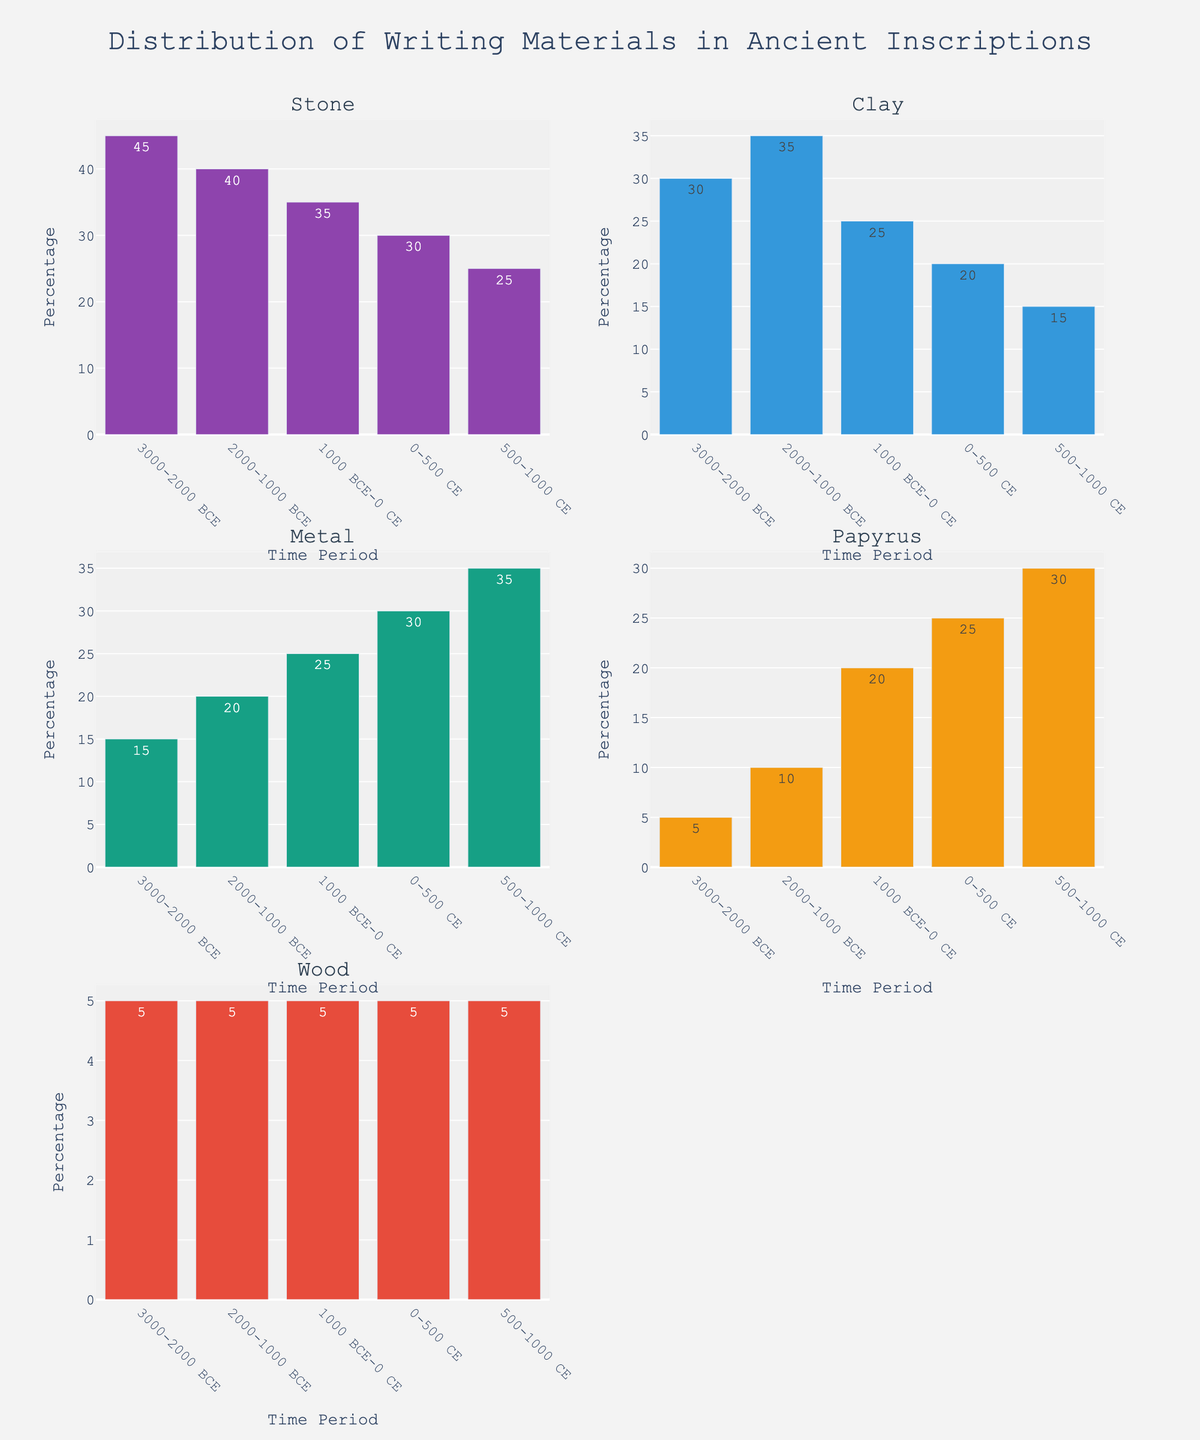What is the title of the figure? The title of the figure is displayed at the top and reads "Native American Population Changes in Western States (1850-1900)."
Answer: Native American Population Changes in Western States (1850-1900) Which state experienced the largest population decrease from 1850 to 1900? To find this, check the population values for each state in 1850 and 1900. The change for California: 32000 - 12000 = 20000, Arizona: 45000 - 20000 = 25000, New Mexico: 60000 - 35000 = 25000, Montana: 20000 - 45000 = -25000 (population increased), Wyoming: 15000 - 34000 = -19000 (population increased). Arizona and New Mexico had the largest decrease of 25000 each.
Answer: Arizona and New Mexico By how much did the Native American population in Montana increase between 1850 and 1900? Look at the populations of Montana in 1850 and 1900. Montana's population in 1850 was 20000 and increased to 45000 in 1900. The increase is 45000 - 20000 = 25000.
Answer: 25000 Which state had the highest population of Native Americans in 1850? The population in 1850 for each state is: California - 32000, Arizona - 45000, New Mexico - 60000, Montana - 20000, and Wyoming - 15000. New Mexico had the highest population with 60000.
Answer: New Mexico In which decade did California's Native American population see the largest decline? Calculate the decline for each decade: 1850-1860: 32000 - 28000 = 4000, 1860-1870: 28000 - 24000 = 4000, 1870-1880: 24000 - 20000 = 4000, 1880-1890: 20000 - 16000 = 4000, 1890-1900: 16000 - 12000 = 4000. Each decade saw a decline of 4000, so there was no single largest decline.
Answer: No single largest decline What is the new population of Native Americans in 1870 for California and Montana combined? Find the populations of California and Montana in 1870. California: 24000, Montana: 30000. Adding them together: 24000 + 30000 = 54000.
Answer: 54000 Which state had a consistent increase in population across all decades shown? Look for a state where the population increases between every decade. Montana's populations were: 1850 - 20000, 1860 - 25000, 1870 - 30000, 1880 - 35000, 1890 - 40000, 1900 - 45000. Montana shows consistent increase.
Answer: Montana What color represents New Mexico in the subplots? The line color represents New Mexico can be identified by checking the sequence of colors used for the subplots. New Mexico is third in the sequence, so the color is '#DEB887' (a shade of beige).
Answer: Beige 